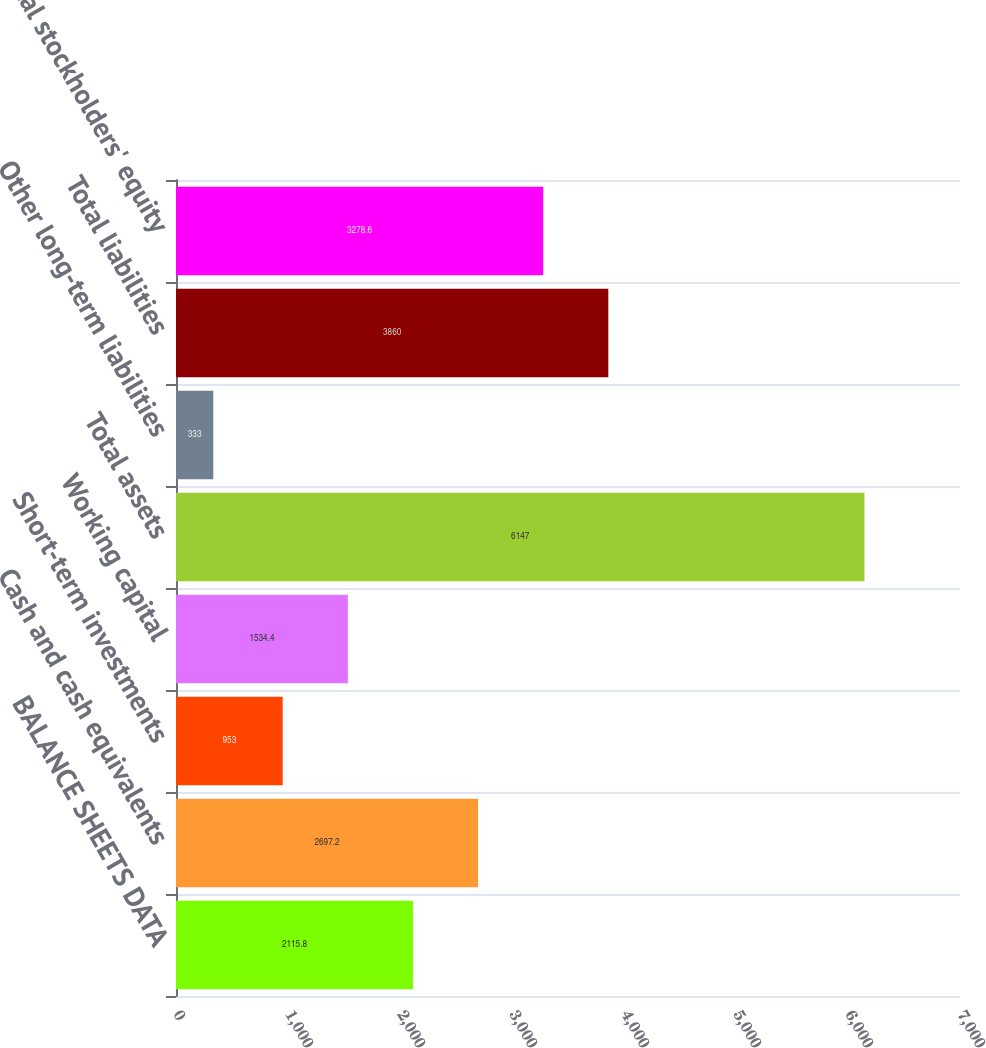Convert chart to OTSL. <chart><loc_0><loc_0><loc_500><loc_500><bar_chart><fcel>BALANCE SHEETS DATA<fcel>Cash and cash equivalents<fcel>Short-term investments<fcel>Working capital<fcel>Total assets<fcel>Other long-term liabilities<fcel>Total liabilities<fcel>Total stockholders' equity<nl><fcel>2115.8<fcel>2697.2<fcel>953<fcel>1534.4<fcel>6147<fcel>333<fcel>3860<fcel>3278.6<nl></chart> 